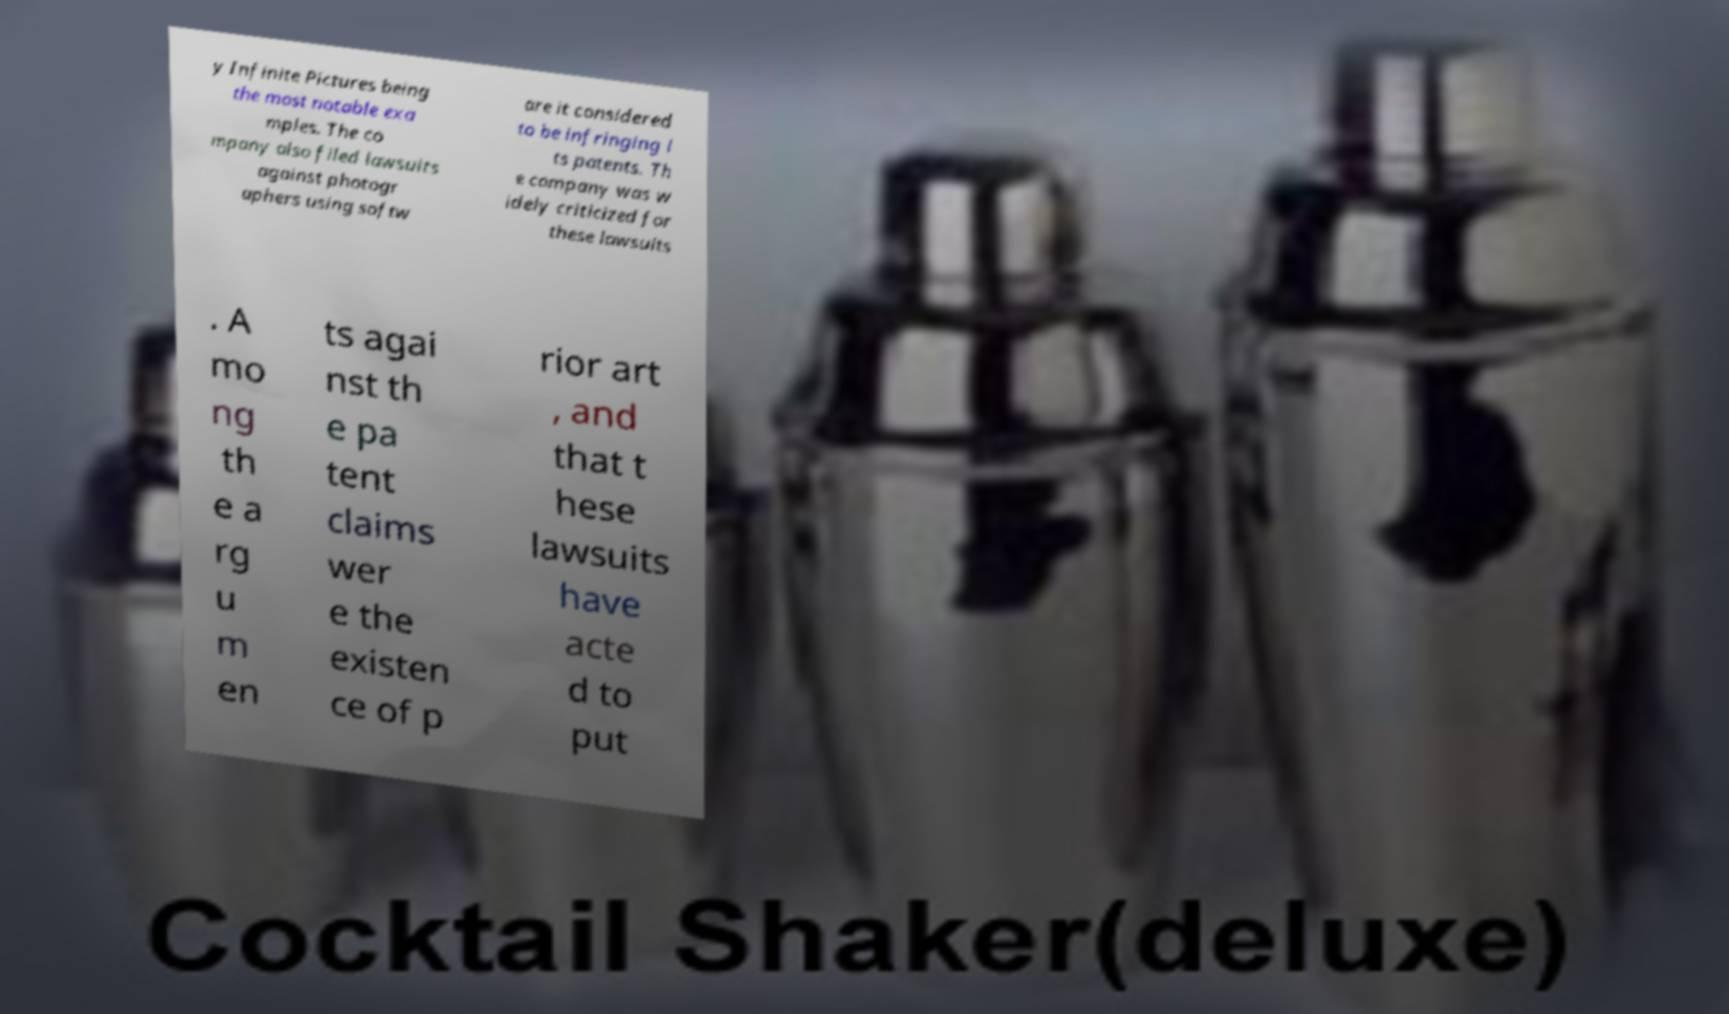Could you assist in decoding the text presented in this image and type it out clearly? y Infinite Pictures being the most notable exa mples. The co mpany also filed lawsuits against photogr aphers using softw are it considered to be infringing i ts patents. Th e company was w idely criticized for these lawsuits . A mo ng th e a rg u m en ts agai nst th e pa tent claims wer e the existen ce of p rior art , and that t hese lawsuits have acte d to put 